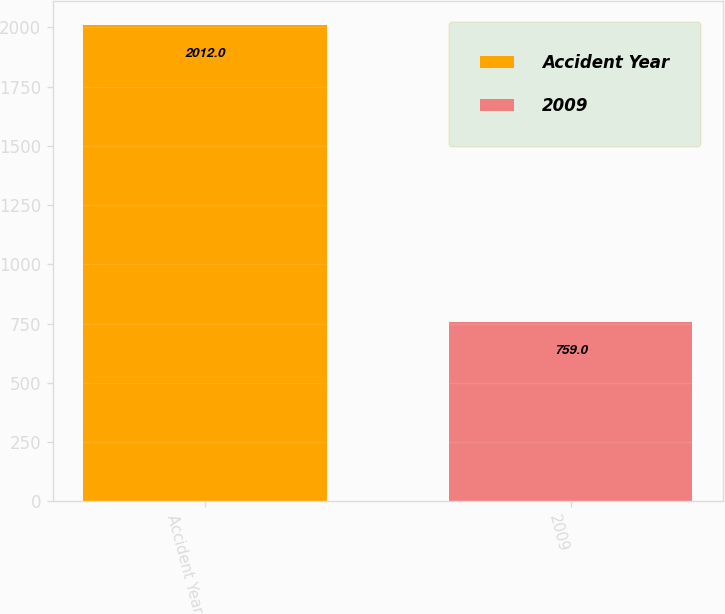Convert chart. <chart><loc_0><loc_0><loc_500><loc_500><bar_chart><fcel>Accident Year<fcel>2009<nl><fcel>2012<fcel>759<nl></chart> 